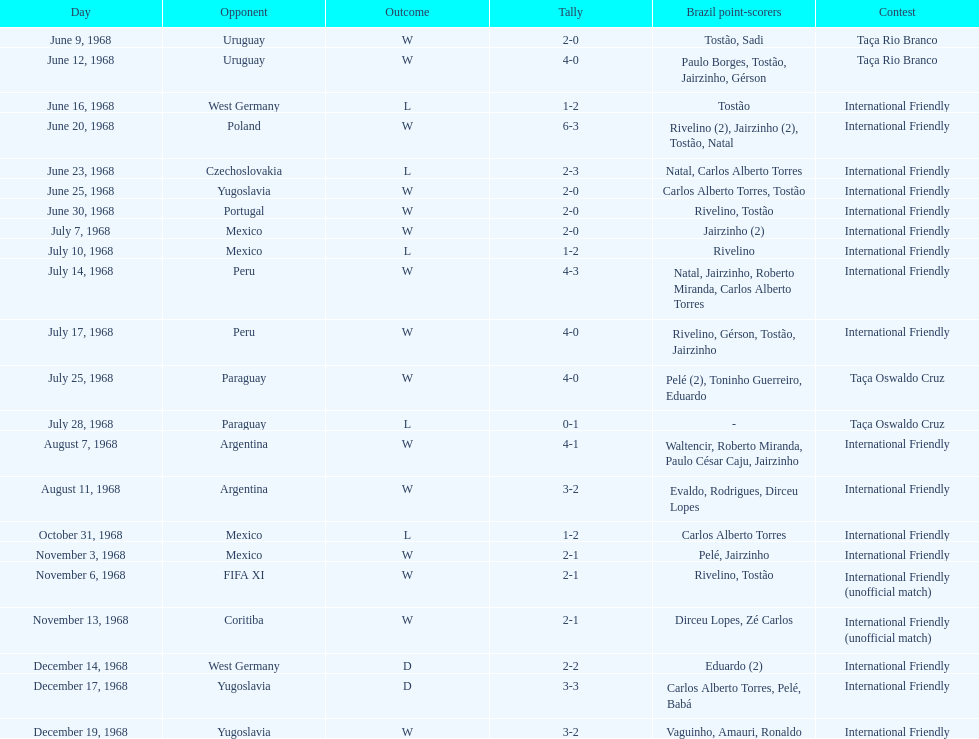Name the first competition ever played by brazil. Taça Rio Branco. 